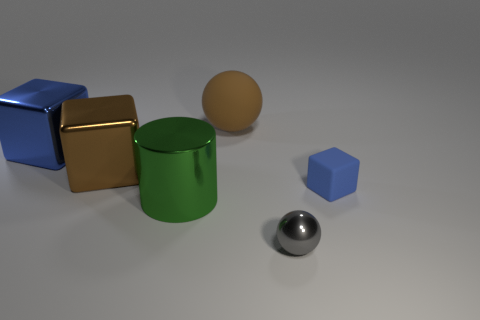Does the shiny cylinder have the same size as the blue rubber cube?
Your response must be concise. No. What color is the small matte object that is the same shape as the big brown metallic object?
Provide a succinct answer. Blue. What number of other large blocks have the same color as the rubber cube?
Keep it short and to the point. 1. Are there more things in front of the large cylinder than tiny cyan metallic blocks?
Provide a succinct answer. Yes. The rubber object behind the blue block that is behind the tiny blue rubber block is what color?
Keep it short and to the point. Brown. What number of objects are blocks behind the cylinder or blue objects that are to the right of the big brown shiny block?
Your answer should be very brief. 3. What color is the metallic cylinder?
Make the answer very short. Green. How many red things have the same material as the cylinder?
Ensure brevity in your answer.  0. Is the number of tiny balls greater than the number of small purple shiny cubes?
Provide a short and direct response. Yes. What number of small metallic balls are behind the shiny object on the right side of the big brown rubber object?
Your answer should be compact. 0. 